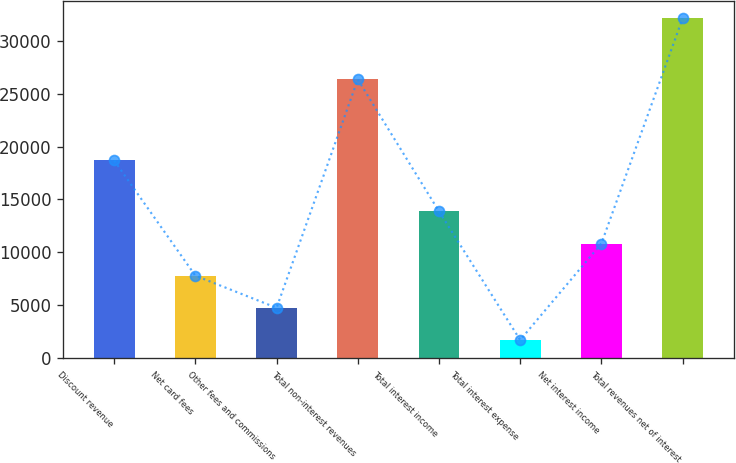<chart> <loc_0><loc_0><loc_500><loc_500><bar_chart><fcel>Discount revenue<fcel>Net card fees<fcel>Other fees and commissions<fcel>Total non-interest revenues<fcel>Total interest income<fcel>Total interest expense<fcel>Net interest income<fcel>Total revenues net of interest<nl><fcel>18680<fcel>7787<fcel>4745.5<fcel>26348<fcel>13870<fcel>1704<fcel>10828.5<fcel>32119<nl></chart> 